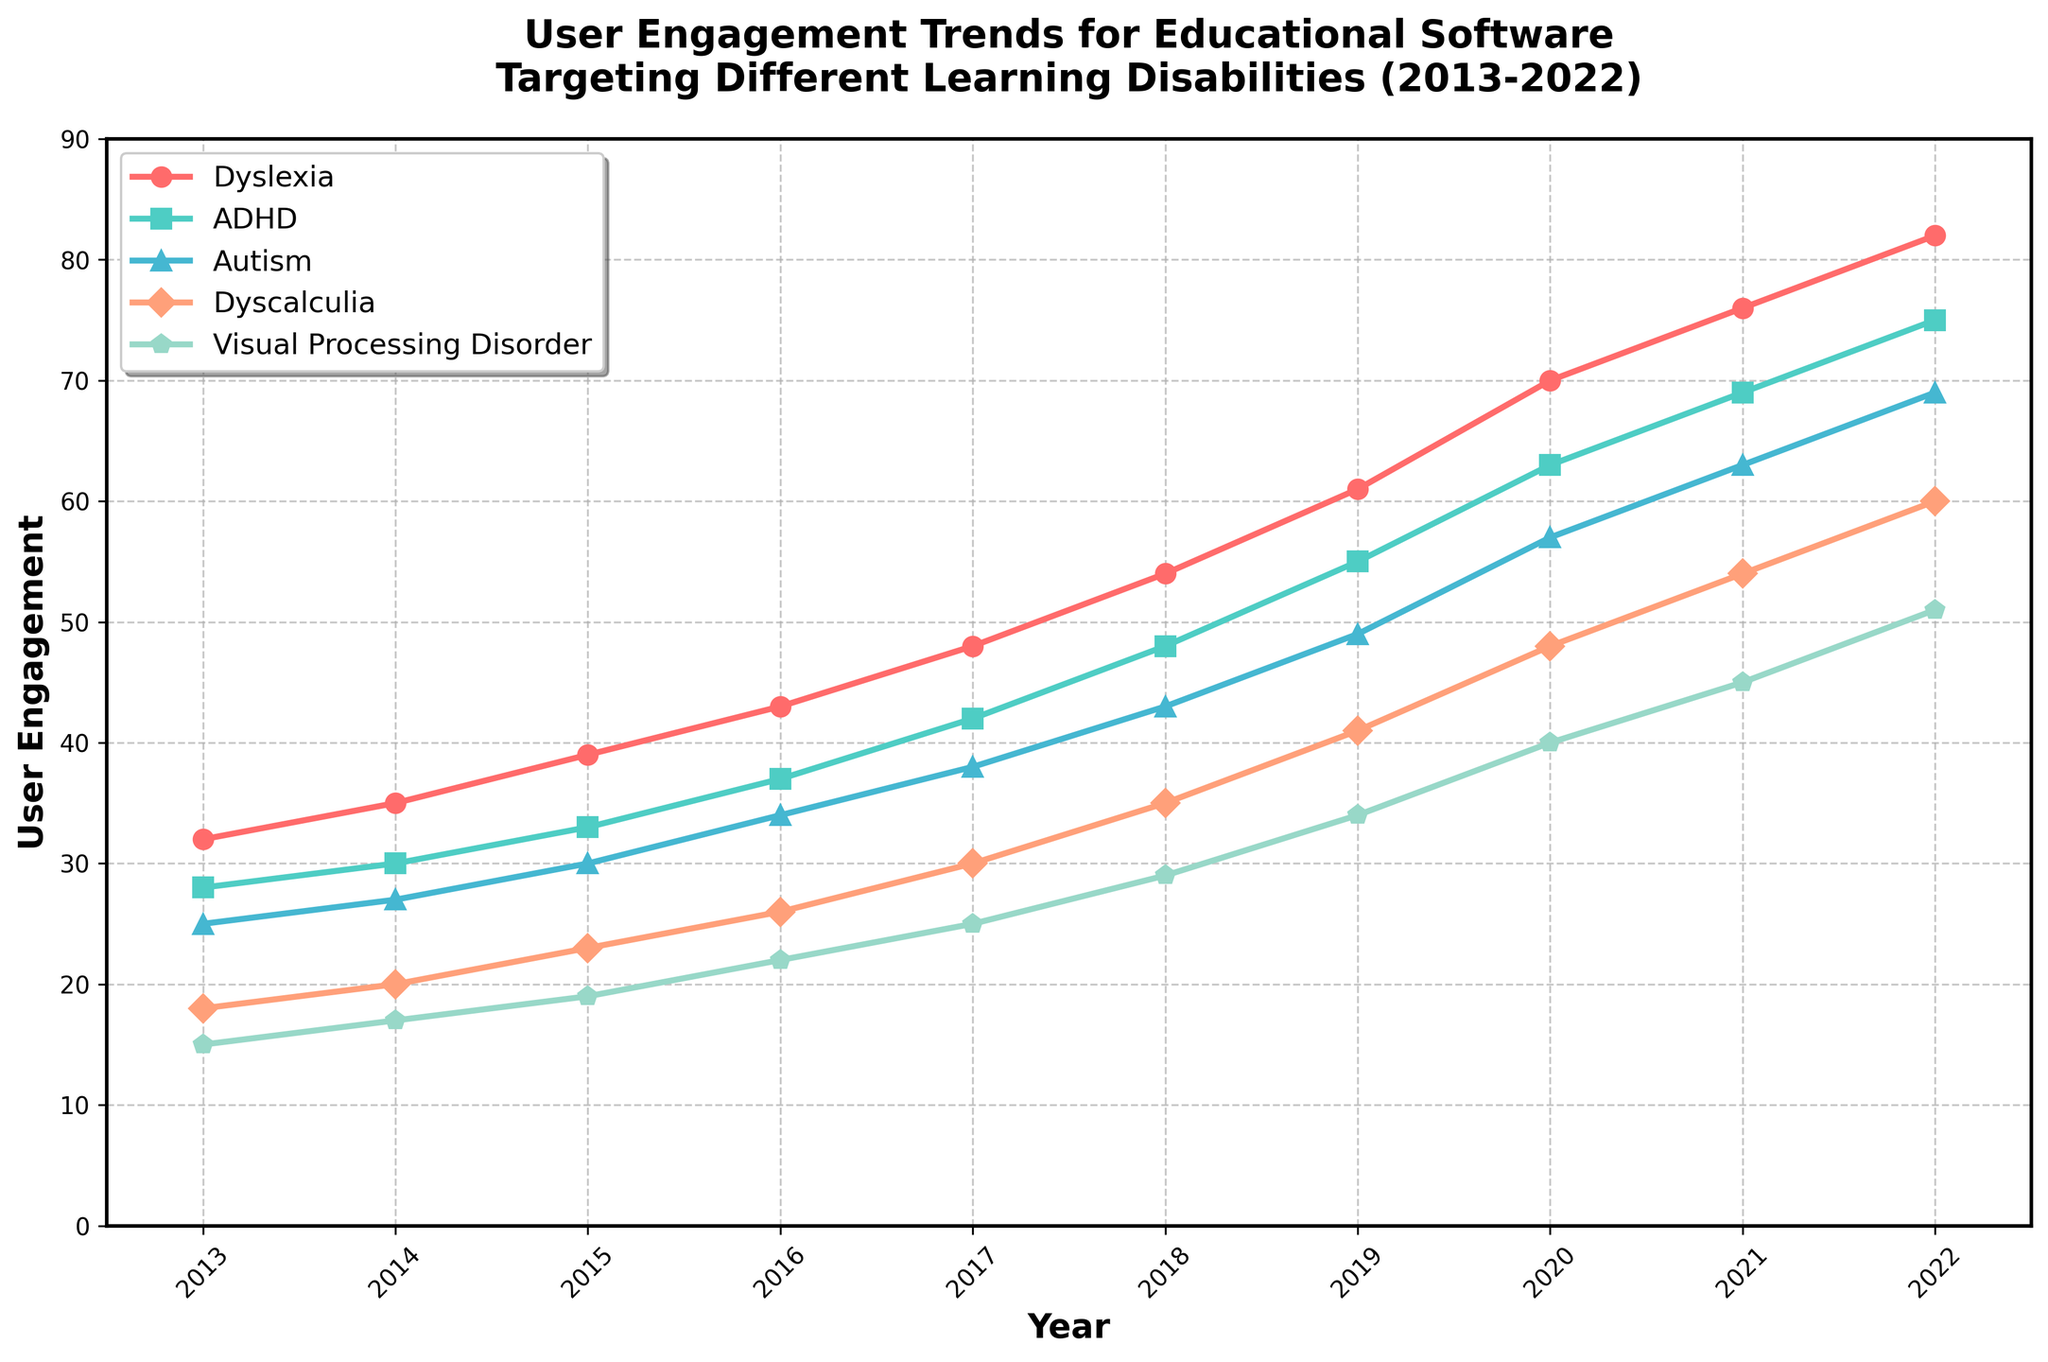Which learning disability had the highest user engagement in 2022? Look at the 2022 data points and compare values. The highest value among the learning disabilities is for Dyslexia.
Answer: Dyslexia How much did user engagement for ADHD increase from 2013 to 2022? Find the values from 2013 and 2022 for ADHD and calculate the difference. In 2013, the engagement was 28, and in 2022, it was 75. The increase is 75 - 28 = 47.
Answer: 47 Which learning disability saw the smallest increase in user engagement from 2013 to 2022? Calculate the increase for each learning disability by subtracting the 2013 value from the 2022 value and compare. The smallest increase is for Visual Processing Disorder (51 - 15 = 36).
Answer: Visual Processing Disorder On average, how much did user engagement for Dyslexia increase per year from 2013 to 2022? The total increase is 82 - 32 = 50. There are 9 intervals (2022-2013). The average increase per year is 50 / 9 ≈ 5.56.
Answer: 5.56 Which learning disability had the least user engagement in 2017? Look at the 2017 data points and find the smallest value. The least engagement was for Visual Processing Disorder (25).
Answer: Visual Processing Disorder In which year did Autism first surpass 40 in user engagement? Look at the data points for Autism and find the year where the value first goes above 40. This happens in 2019 (49).
Answer: 2019 How many years did it take for Dyslexia to double its user engagement starting from 2013? Initially, Dyslexia's engagement was 32. Doubling it means reaching 64. Dyslexia surpassed 64 in 2020 with a value of 70.
Answer: 7 years Add up the user engagement values for ADHD and Dyscalculia in 2016. Find the 2016 values for ADHD (37) and Dyscalculia (26) and sum them up: 37 + 26 = 63.
Answer: 63 Compare the user engagement trends of Dyslexia and Autism from 2013 to 2022. Which one grew faster? Calculate the total increase for each: Dyslexia (82-32 = 50) and Autism (69-25 = 44). Dyslexia's increase (50) is greater than Autism's increase (44), so Dyslexia grew faster.
Answer: Dyslexia 